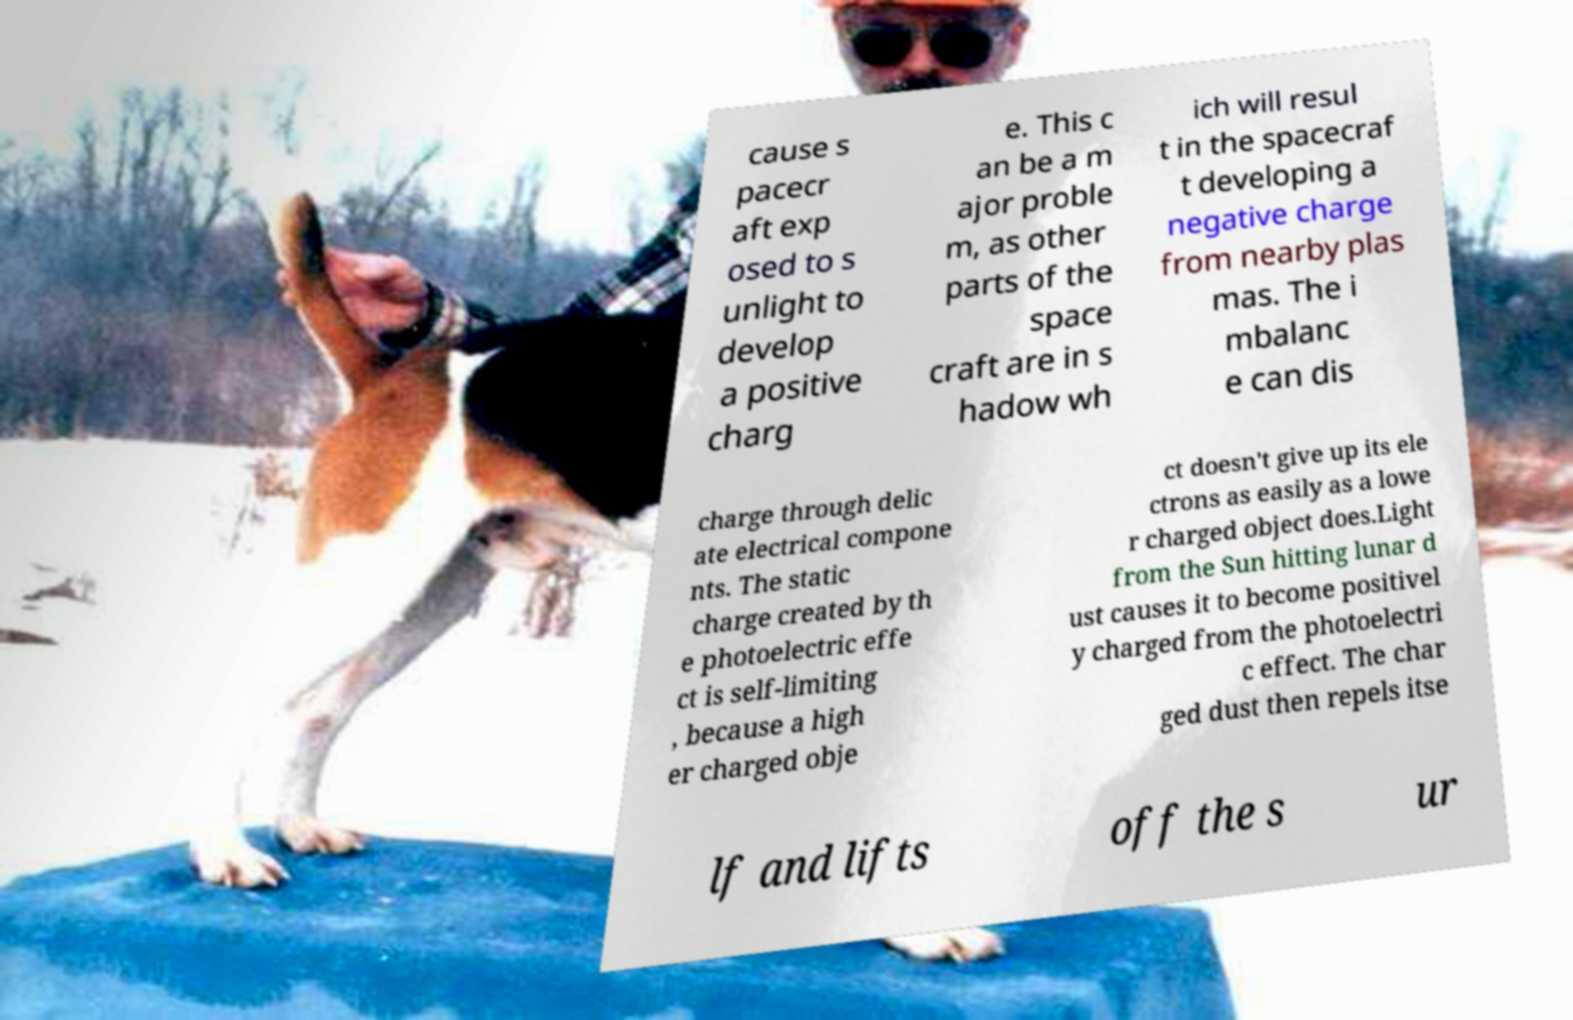I need the written content from this picture converted into text. Can you do that? cause s pacecr aft exp osed to s unlight to develop a positive charg e. This c an be a m ajor proble m, as other parts of the space craft are in s hadow wh ich will resul t in the spacecraf t developing a negative charge from nearby plas mas. The i mbalanc e can dis charge through delic ate electrical compone nts. The static charge created by th e photoelectric effe ct is self-limiting , because a high er charged obje ct doesn't give up its ele ctrons as easily as a lowe r charged object does.Light from the Sun hitting lunar d ust causes it to become positivel y charged from the photoelectri c effect. The char ged dust then repels itse lf and lifts off the s ur 